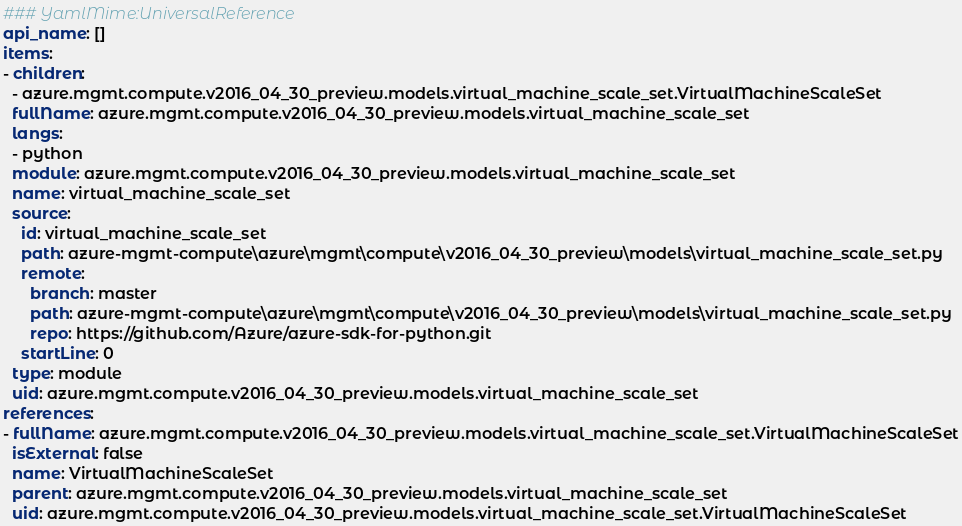<code> <loc_0><loc_0><loc_500><loc_500><_YAML_>### YamlMime:UniversalReference
api_name: []
items:
- children:
  - azure.mgmt.compute.v2016_04_30_preview.models.virtual_machine_scale_set.VirtualMachineScaleSet
  fullName: azure.mgmt.compute.v2016_04_30_preview.models.virtual_machine_scale_set
  langs:
  - python
  module: azure.mgmt.compute.v2016_04_30_preview.models.virtual_machine_scale_set
  name: virtual_machine_scale_set
  source:
    id: virtual_machine_scale_set
    path: azure-mgmt-compute\azure\mgmt\compute\v2016_04_30_preview\models\virtual_machine_scale_set.py
    remote:
      branch: master
      path: azure-mgmt-compute\azure\mgmt\compute\v2016_04_30_preview\models\virtual_machine_scale_set.py
      repo: https://github.com/Azure/azure-sdk-for-python.git
    startLine: 0
  type: module
  uid: azure.mgmt.compute.v2016_04_30_preview.models.virtual_machine_scale_set
references:
- fullName: azure.mgmt.compute.v2016_04_30_preview.models.virtual_machine_scale_set.VirtualMachineScaleSet
  isExternal: false
  name: VirtualMachineScaleSet
  parent: azure.mgmt.compute.v2016_04_30_preview.models.virtual_machine_scale_set
  uid: azure.mgmt.compute.v2016_04_30_preview.models.virtual_machine_scale_set.VirtualMachineScaleSet
</code> 